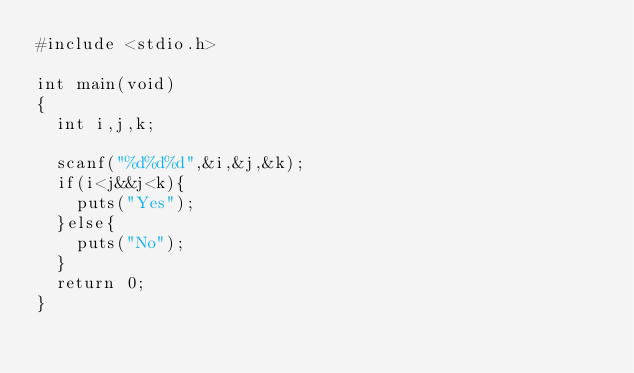<code> <loc_0><loc_0><loc_500><loc_500><_C_>#include <stdio.h>

int main(void)
{
  int i,j,k;

  scanf("%d%d%d",&i,&j,&k);
  if(i<j&&j<k){
    puts("Yes");
  }else{
    puts("No");
  }
  return 0;
}

</code> 